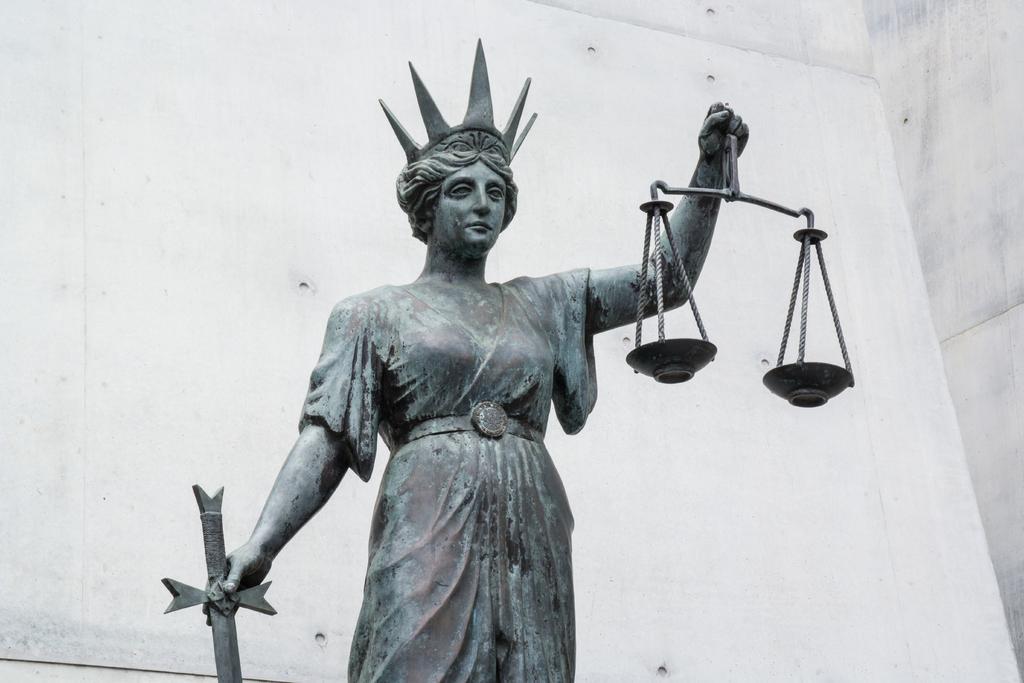Can you describe this image briefly? In this image there is a statue holding some objects and there is a wall. 